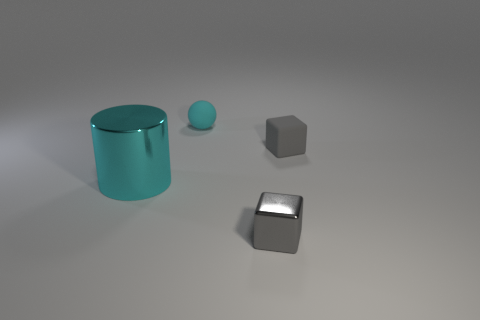Add 2 cyan spheres. How many objects exist? 6 Subtract all balls. How many objects are left? 3 Subtract all cubes. Subtract all big red objects. How many objects are left? 2 Add 4 big cyan cylinders. How many big cyan cylinders are left? 5 Add 4 tiny cyan things. How many tiny cyan things exist? 5 Subtract 0 green balls. How many objects are left? 4 